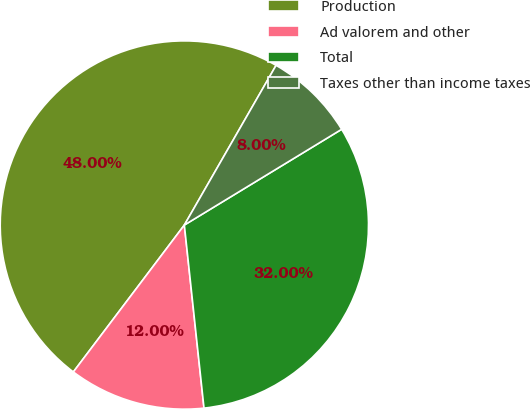Convert chart to OTSL. <chart><loc_0><loc_0><loc_500><loc_500><pie_chart><fcel>Production<fcel>Ad valorem and other<fcel>Total<fcel>Taxes other than income taxes<nl><fcel>48.0%<fcel>12.0%<fcel>32.0%<fcel>8.0%<nl></chart> 